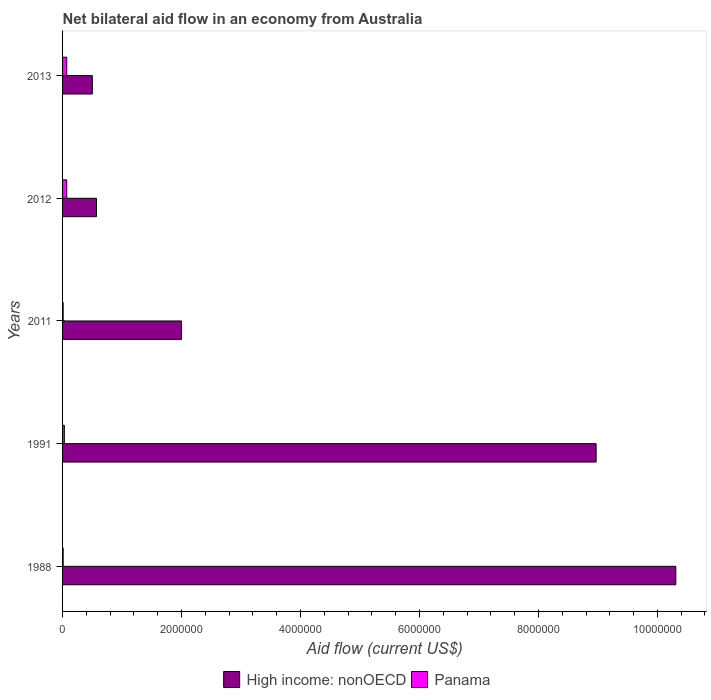How many different coloured bars are there?
Ensure brevity in your answer.  2. How many groups of bars are there?
Your answer should be very brief. 5. Are the number of bars on each tick of the Y-axis equal?
Offer a very short reply. Yes. How many bars are there on the 4th tick from the top?
Your response must be concise. 2. What is the label of the 2nd group of bars from the top?
Your response must be concise. 2012. What is the net bilateral aid flow in High income: nonOECD in 1991?
Keep it short and to the point. 8.97e+06. Across all years, what is the maximum net bilateral aid flow in Panama?
Offer a terse response. 7.00e+04. Across all years, what is the minimum net bilateral aid flow in High income: nonOECD?
Give a very brief answer. 5.00e+05. In which year was the net bilateral aid flow in High income: nonOECD minimum?
Your response must be concise. 2013. What is the difference between the net bilateral aid flow in Panama in 2011 and that in 2012?
Your answer should be compact. -6.00e+04. What is the difference between the net bilateral aid flow in Panama in 2011 and the net bilateral aid flow in High income: nonOECD in 1988?
Your answer should be compact. -1.03e+07. What is the average net bilateral aid flow in Panama per year?
Ensure brevity in your answer.  3.80e+04. What is the ratio of the net bilateral aid flow in Panama in 2011 to that in 2013?
Give a very brief answer. 0.14. What is the difference between the highest and the second highest net bilateral aid flow in Panama?
Your response must be concise. 0. What is the difference between the highest and the lowest net bilateral aid flow in Panama?
Ensure brevity in your answer.  6.00e+04. In how many years, is the net bilateral aid flow in High income: nonOECD greater than the average net bilateral aid flow in High income: nonOECD taken over all years?
Offer a very short reply. 2. Is the sum of the net bilateral aid flow in Panama in 2012 and 2013 greater than the maximum net bilateral aid flow in High income: nonOECD across all years?
Offer a very short reply. No. What does the 1st bar from the top in 2013 represents?
Your answer should be compact. Panama. What does the 2nd bar from the bottom in 2012 represents?
Keep it short and to the point. Panama. How many bars are there?
Your response must be concise. 10. Does the graph contain grids?
Your answer should be compact. No. Where does the legend appear in the graph?
Provide a short and direct response. Bottom center. How are the legend labels stacked?
Your answer should be compact. Horizontal. What is the title of the graph?
Offer a terse response. Net bilateral aid flow in an economy from Australia. What is the label or title of the X-axis?
Offer a terse response. Aid flow (current US$). What is the label or title of the Y-axis?
Keep it short and to the point. Years. What is the Aid flow (current US$) of High income: nonOECD in 1988?
Provide a succinct answer. 1.03e+07. What is the Aid flow (current US$) of High income: nonOECD in 1991?
Provide a short and direct response. 8.97e+06. What is the Aid flow (current US$) in High income: nonOECD in 2011?
Your answer should be very brief. 2.00e+06. What is the Aid flow (current US$) in Panama in 2011?
Provide a short and direct response. 10000. What is the Aid flow (current US$) in High income: nonOECD in 2012?
Make the answer very short. 5.70e+05. What is the Aid flow (current US$) in Panama in 2013?
Your response must be concise. 7.00e+04. Across all years, what is the maximum Aid flow (current US$) of High income: nonOECD?
Provide a succinct answer. 1.03e+07. Across all years, what is the maximum Aid flow (current US$) of Panama?
Provide a short and direct response. 7.00e+04. Across all years, what is the minimum Aid flow (current US$) of High income: nonOECD?
Your answer should be very brief. 5.00e+05. What is the total Aid flow (current US$) of High income: nonOECD in the graph?
Provide a short and direct response. 2.24e+07. What is the difference between the Aid flow (current US$) in High income: nonOECD in 1988 and that in 1991?
Provide a succinct answer. 1.34e+06. What is the difference between the Aid flow (current US$) in Panama in 1988 and that in 1991?
Make the answer very short. -2.00e+04. What is the difference between the Aid flow (current US$) of High income: nonOECD in 1988 and that in 2011?
Give a very brief answer. 8.31e+06. What is the difference between the Aid flow (current US$) in Panama in 1988 and that in 2011?
Your answer should be very brief. 0. What is the difference between the Aid flow (current US$) of High income: nonOECD in 1988 and that in 2012?
Your response must be concise. 9.74e+06. What is the difference between the Aid flow (current US$) of High income: nonOECD in 1988 and that in 2013?
Provide a short and direct response. 9.81e+06. What is the difference between the Aid flow (current US$) of Panama in 1988 and that in 2013?
Your answer should be compact. -6.00e+04. What is the difference between the Aid flow (current US$) of High income: nonOECD in 1991 and that in 2011?
Give a very brief answer. 6.97e+06. What is the difference between the Aid flow (current US$) in High income: nonOECD in 1991 and that in 2012?
Give a very brief answer. 8.40e+06. What is the difference between the Aid flow (current US$) in Panama in 1991 and that in 2012?
Provide a succinct answer. -4.00e+04. What is the difference between the Aid flow (current US$) in High income: nonOECD in 1991 and that in 2013?
Offer a very short reply. 8.47e+06. What is the difference between the Aid flow (current US$) in Panama in 1991 and that in 2013?
Provide a short and direct response. -4.00e+04. What is the difference between the Aid flow (current US$) in High income: nonOECD in 2011 and that in 2012?
Keep it short and to the point. 1.43e+06. What is the difference between the Aid flow (current US$) in Panama in 2011 and that in 2012?
Provide a succinct answer. -6.00e+04. What is the difference between the Aid flow (current US$) in High income: nonOECD in 2011 and that in 2013?
Your response must be concise. 1.50e+06. What is the difference between the Aid flow (current US$) of High income: nonOECD in 1988 and the Aid flow (current US$) of Panama in 1991?
Give a very brief answer. 1.03e+07. What is the difference between the Aid flow (current US$) in High income: nonOECD in 1988 and the Aid flow (current US$) in Panama in 2011?
Your answer should be compact. 1.03e+07. What is the difference between the Aid flow (current US$) in High income: nonOECD in 1988 and the Aid flow (current US$) in Panama in 2012?
Your answer should be very brief. 1.02e+07. What is the difference between the Aid flow (current US$) of High income: nonOECD in 1988 and the Aid flow (current US$) of Panama in 2013?
Your answer should be very brief. 1.02e+07. What is the difference between the Aid flow (current US$) in High income: nonOECD in 1991 and the Aid flow (current US$) in Panama in 2011?
Provide a short and direct response. 8.96e+06. What is the difference between the Aid flow (current US$) in High income: nonOECD in 1991 and the Aid flow (current US$) in Panama in 2012?
Your response must be concise. 8.90e+06. What is the difference between the Aid flow (current US$) in High income: nonOECD in 1991 and the Aid flow (current US$) in Panama in 2013?
Your answer should be very brief. 8.90e+06. What is the difference between the Aid flow (current US$) of High income: nonOECD in 2011 and the Aid flow (current US$) of Panama in 2012?
Your answer should be compact. 1.93e+06. What is the difference between the Aid flow (current US$) in High income: nonOECD in 2011 and the Aid flow (current US$) in Panama in 2013?
Offer a very short reply. 1.93e+06. What is the average Aid flow (current US$) in High income: nonOECD per year?
Your response must be concise. 4.47e+06. What is the average Aid flow (current US$) of Panama per year?
Your answer should be compact. 3.80e+04. In the year 1988, what is the difference between the Aid flow (current US$) of High income: nonOECD and Aid flow (current US$) of Panama?
Your answer should be compact. 1.03e+07. In the year 1991, what is the difference between the Aid flow (current US$) in High income: nonOECD and Aid flow (current US$) in Panama?
Your answer should be very brief. 8.94e+06. In the year 2011, what is the difference between the Aid flow (current US$) of High income: nonOECD and Aid flow (current US$) of Panama?
Provide a succinct answer. 1.99e+06. In the year 2012, what is the difference between the Aid flow (current US$) in High income: nonOECD and Aid flow (current US$) in Panama?
Offer a very short reply. 5.00e+05. What is the ratio of the Aid flow (current US$) in High income: nonOECD in 1988 to that in 1991?
Your answer should be very brief. 1.15. What is the ratio of the Aid flow (current US$) of High income: nonOECD in 1988 to that in 2011?
Make the answer very short. 5.16. What is the ratio of the Aid flow (current US$) of Panama in 1988 to that in 2011?
Your answer should be compact. 1. What is the ratio of the Aid flow (current US$) of High income: nonOECD in 1988 to that in 2012?
Make the answer very short. 18.09. What is the ratio of the Aid flow (current US$) of Panama in 1988 to that in 2012?
Offer a terse response. 0.14. What is the ratio of the Aid flow (current US$) in High income: nonOECD in 1988 to that in 2013?
Provide a short and direct response. 20.62. What is the ratio of the Aid flow (current US$) of Panama in 1988 to that in 2013?
Keep it short and to the point. 0.14. What is the ratio of the Aid flow (current US$) of High income: nonOECD in 1991 to that in 2011?
Ensure brevity in your answer.  4.49. What is the ratio of the Aid flow (current US$) of Panama in 1991 to that in 2011?
Provide a short and direct response. 3. What is the ratio of the Aid flow (current US$) of High income: nonOECD in 1991 to that in 2012?
Your answer should be compact. 15.74. What is the ratio of the Aid flow (current US$) in Panama in 1991 to that in 2012?
Ensure brevity in your answer.  0.43. What is the ratio of the Aid flow (current US$) in High income: nonOECD in 1991 to that in 2013?
Give a very brief answer. 17.94. What is the ratio of the Aid flow (current US$) in Panama in 1991 to that in 2013?
Offer a terse response. 0.43. What is the ratio of the Aid flow (current US$) in High income: nonOECD in 2011 to that in 2012?
Provide a succinct answer. 3.51. What is the ratio of the Aid flow (current US$) in Panama in 2011 to that in 2012?
Your answer should be very brief. 0.14. What is the ratio of the Aid flow (current US$) in Panama in 2011 to that in 2013?
Provide a succinct answer. 0.14. What is the ratio of the Aid flow (current US$) in High income: nonOECD in 2012 to that in 2013?
Your answer should be compact. 1.14. What is the difference between the highest and the second highest Aid flow (current US$) of High income: nonOECD?
Offer a terse response. 1.34e+06. What is the difference between the highest and the second highest Aid flow (current US$) of Panama?
Provide a short and direct response. 0. What is the difference between the highest and the lowest Aid flow (current US$) of High income: nonOECD?
Ensure brevity in your answer.  9.81e+06. 